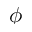<formula> <loc_0><loc_0><loc_500><loc_500>\phi</formula> 